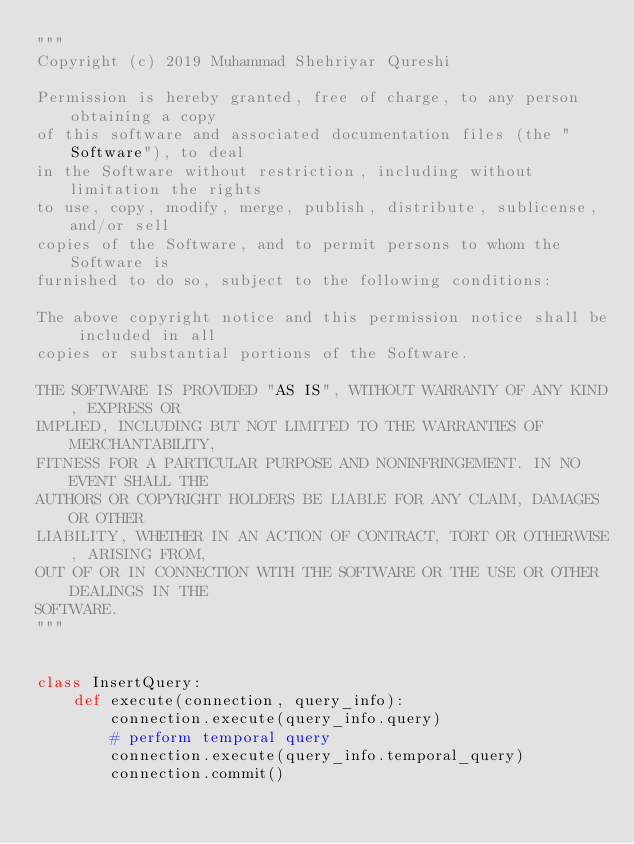Convert code to text. <code><loc_0><loc_0><loc_500><loc_500><_Python_>"""
Copyright (c) 2019 Muhammad Shehriyar Qureshi

Permission is hereby granted, free of charge, to any person obtaining a copy
of this software and associated documentation files (the "Software"), to deal
in the Software without restriction, including without limitation the rights
to use, copy, modify, merge, publish, distribute, sublicense, and/or sell
copies of the Software, and to permit persons to whom the Software is
furnished to do so, subject to the following conditions:

The above copyright notice and this permission notice shall be included in all
copies or substantial portions of the Software.

THE SOFTWARE IS PROVIDED "AS IS", WITHOUT WARRANTY OF ANY KIND, EXPRESS OR
IMPLIED, INCLUDING BUT NOT LIMITED TO THE WARRANTIES OF MERCHANTABILITY,
FITNESS FOR A PARTICULAR PURPOSE AND NONINFRINGEMENT. IN NO EVENT SHALL THE
AUTHORS OR COPYRIGHT HOLDERS BE LIABLE FOR ANY CLAIM, DAMAGES OR OTHER
LIABILITY, WHETHER IN AN ACTION OF CONTRACT, TORT OR OTHERWISE, ARISING FROM,
OUT OF OR IN CONNECTION WITH THE SOFTWARE OR THE USE OR OTHER DEALINGS IN THE
SOFTWARE.
"""


class InsertQuery:
    def execute(connection, query_info):
        connection.execute(query_info.query)
        # perform temporal query
        connection.execute(query_info.temporal_query)
        connection.commit()
</code> 